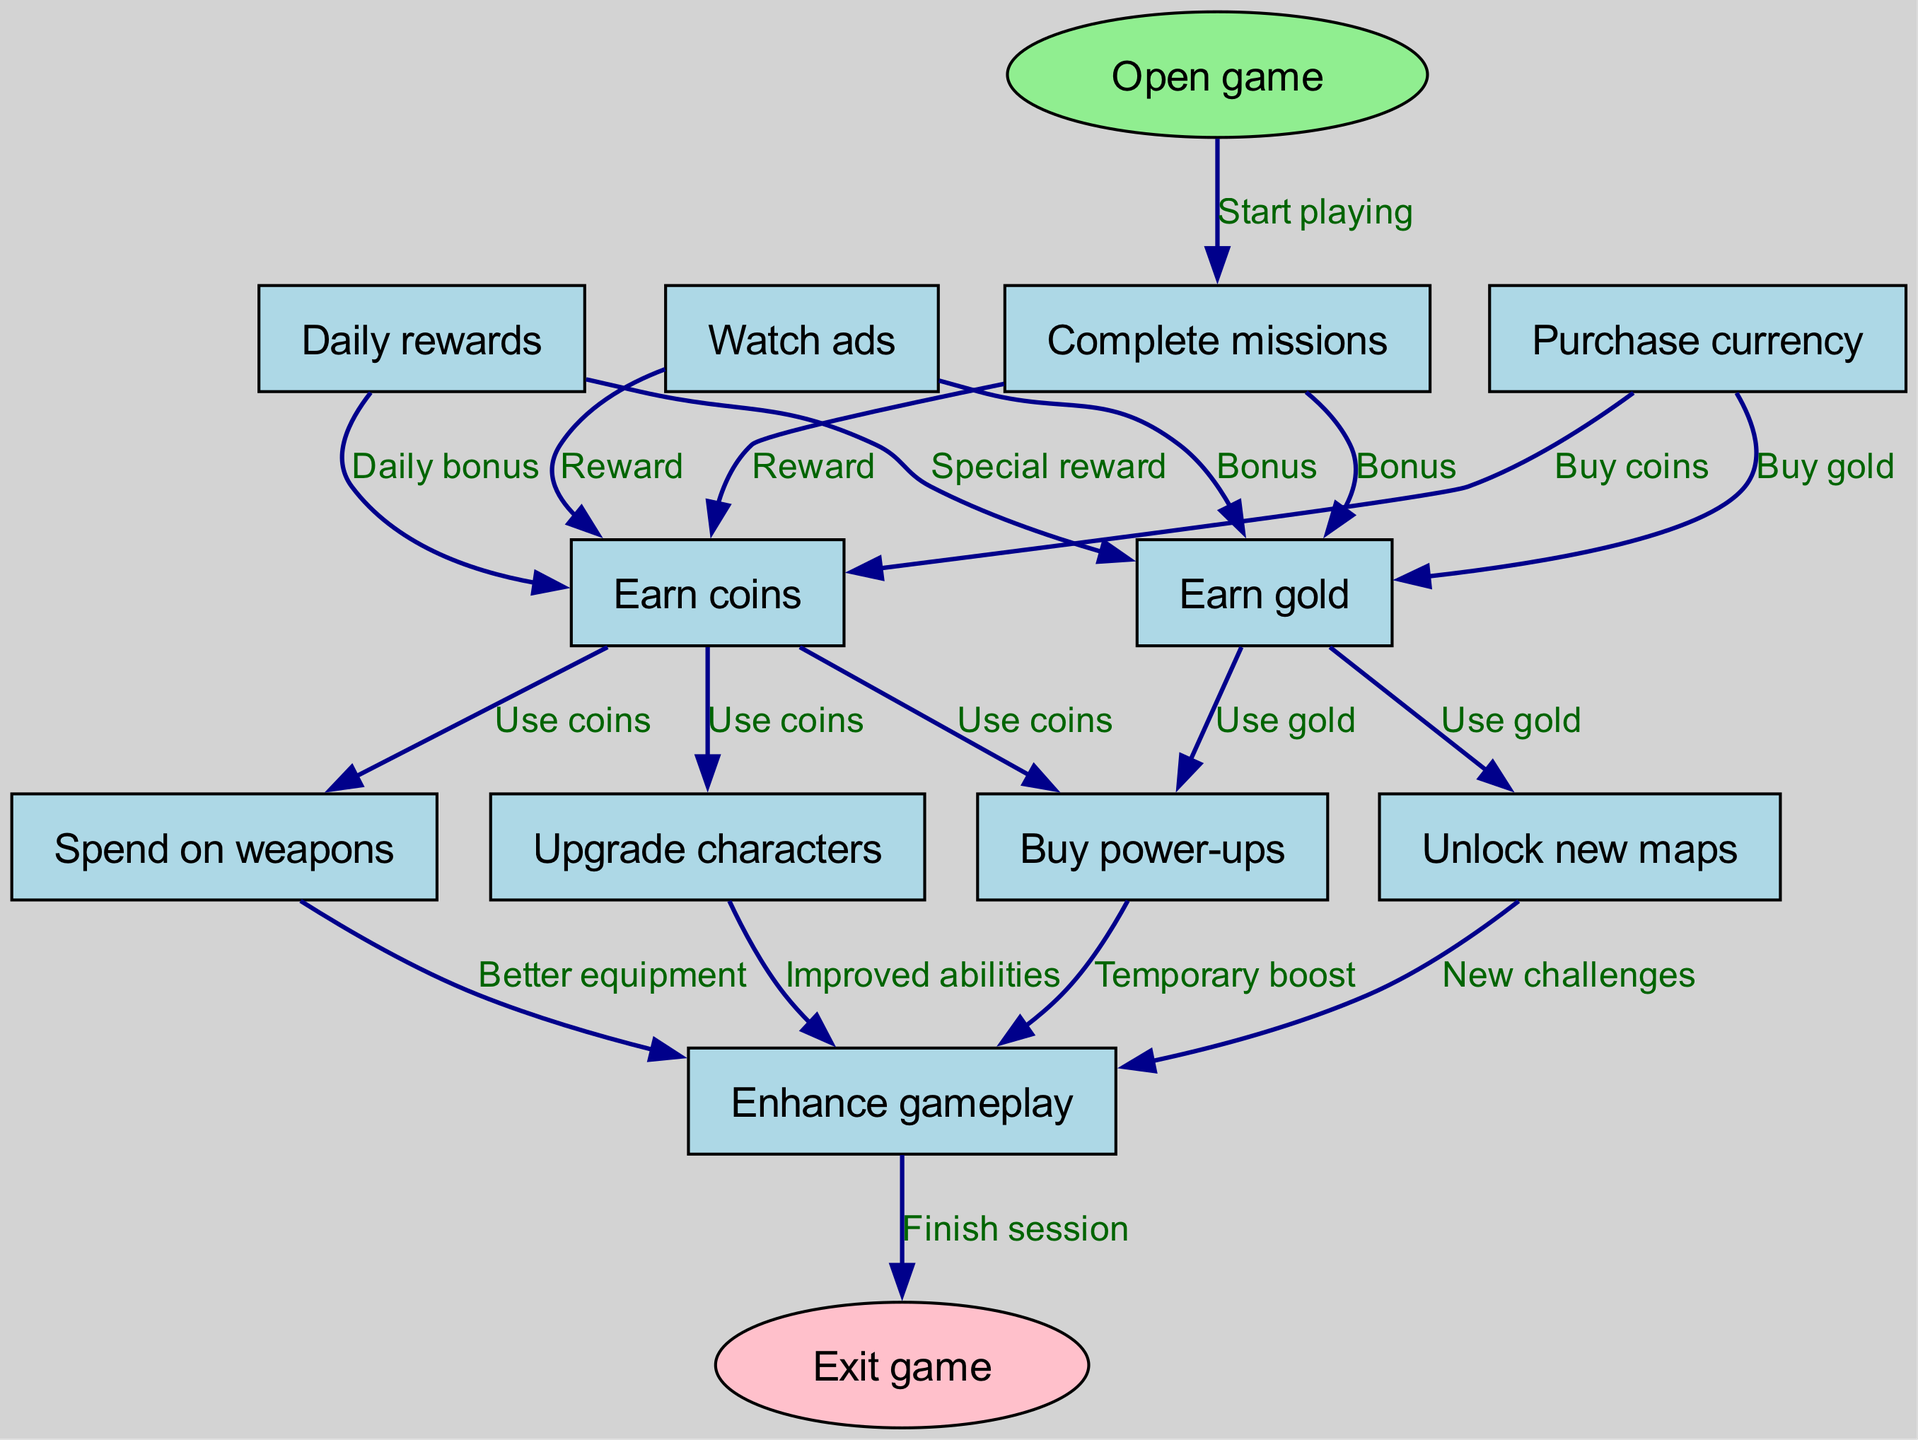What is the starting point of the flow diagram? The flow diagram begins with the node labeled "Open game," indicating the initial action required to enter the game.
Answer: Open game How many main nodes are there in the diagram? The main nodes listed in the diagram include "Complete missions," "Watch ads," "Daily rewards," "Purchase currency," "Spend on weapons," "Upgrade characters," "Buy power-ups," and "Unlock new maps," which total to 8 nodes.
Answer: 8 What can be earned by completing missions? Completing missions yields rewards categorized as "coins" and "gold," both indicated to be earned from that action.
Answer: Coins, Gold What is the result of spending on weapons? Spending on weapons directly leads to the outcome described as "Enhance gameplay," which signifies an improvement in how the game is played.
Answer: Enhance gameplay How do you unlock new maps? Unlocking new maps requires the use of "gold," as indicated in the flow between earning gold and unlocking new maps.
Answer: Use gold Which action provides a daily bonus? The action that offers a daily bonus is "Daily rewards," which contributes to earning coins as a part of the cycle.
Answer: Daily rewards What is the last action before exiting the game? The final action in the cycle leading to exiting the game is "Enhance gameplay," which indicates the reaping of benefits before ending the session.
Answer: Enhance gameplay What do both "Watch ads" and "Daily rewards" have in common? Both "Watch ads" and "Daily rewards" provide rewards in the form of "coins" and "gold," making these actions similar in their outcomes.
Answer: Earn coins, Earn gold Which activity allows you to enhance gameplay temporarily? The activity that offers a temporary boost to enhance gameplay is "Buy power-ups," highlighting a way to gain immediate benefits in the game.
Answer: Buy power-ups 